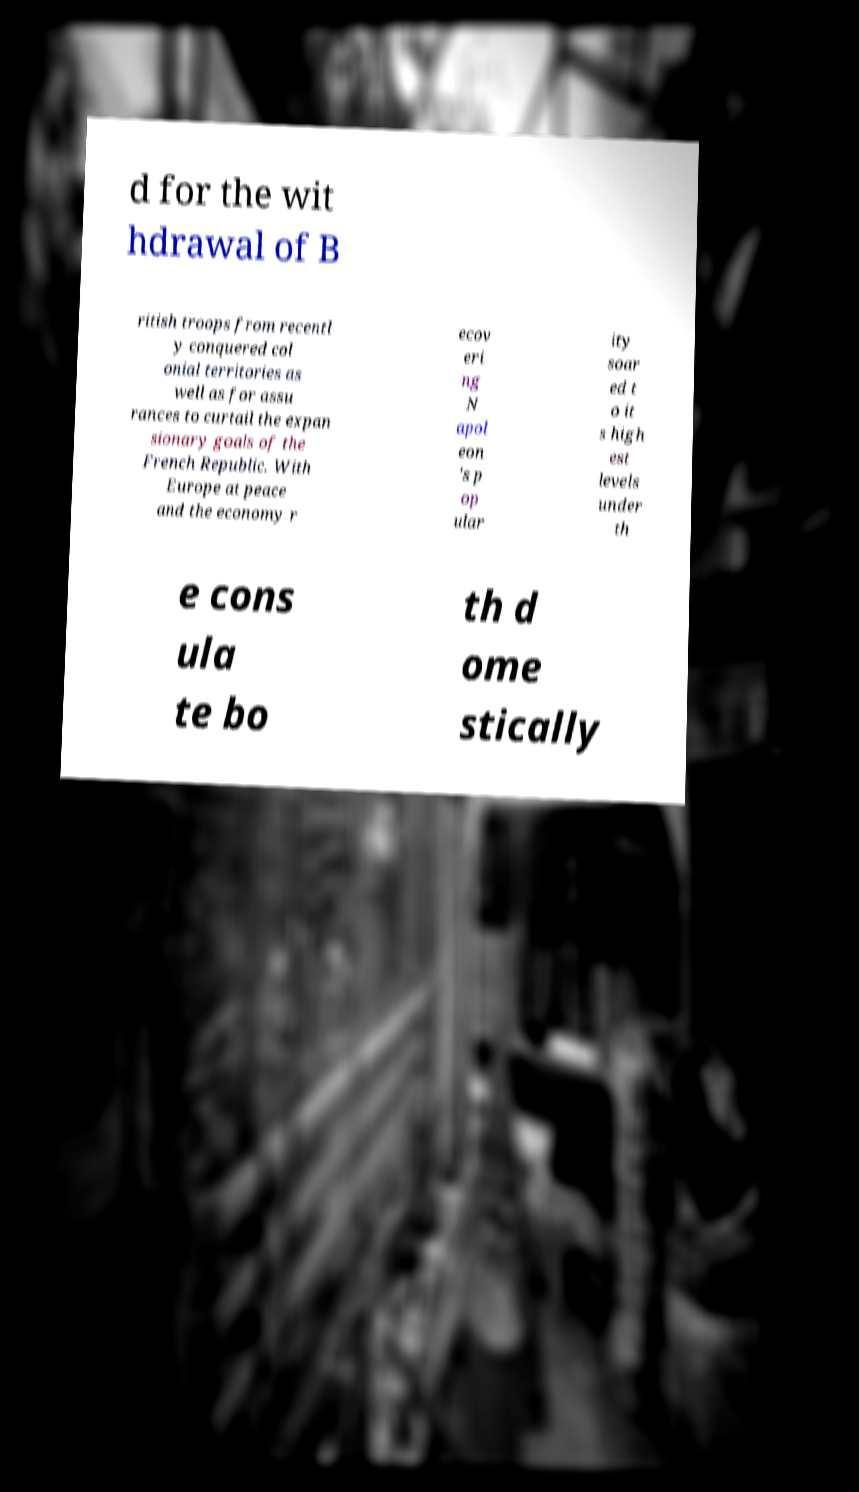Can you accurately transcribe the text from the provided image for me? d for the wit hdrawal of B ritish troops from recentl y conquered col onial territories as well as for assu rances to curtail the expan sionary goals of the French Republic. With Europe at peace and the economy r ecov eri ng N apol eon 's p op ular ity soar ed t o it s high est levels under th e cons ula te bo th d ome stically 